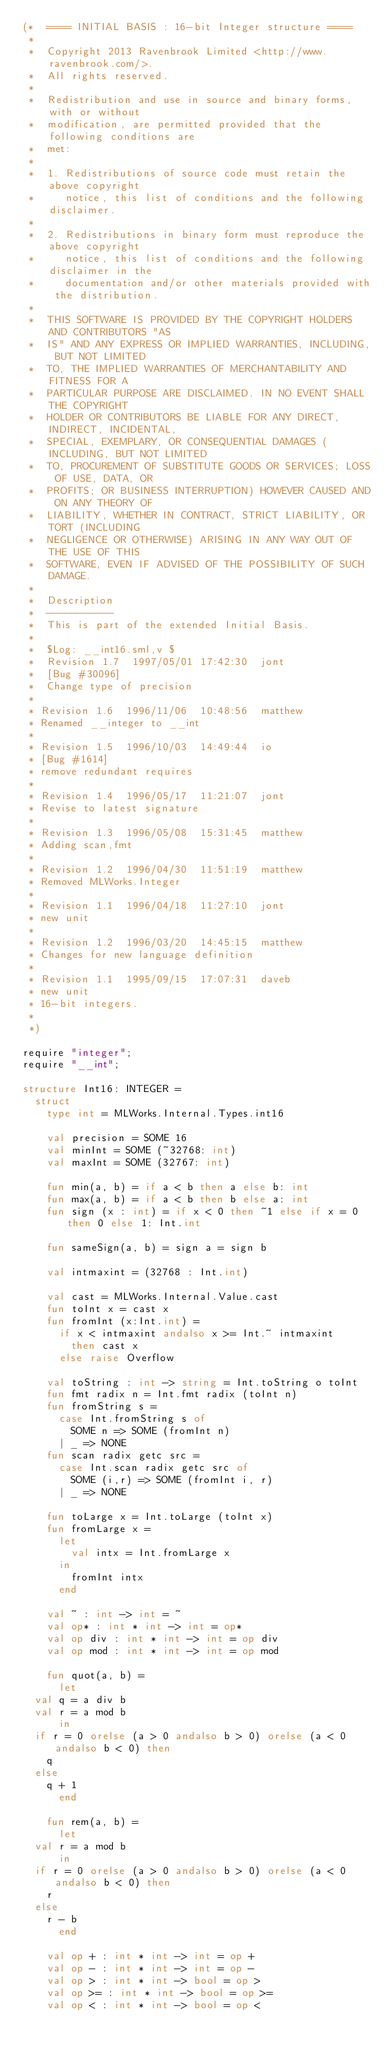<code> <loc_0><loc_0><loc_500><loc_500><_SML_>(*  ==== INITIAL BASIS : 16-bit Integer structure ====
 *
 *  Copyright 2013 Ravenbrook Limited <http://www.ravenbrook.com/>.
 *  All rights reserved.
 *  
 *  Redistribution and use in source and binary forms, with or without
 *  modification, are permitted provided that the following conditions are
 *  met:
 *  
 *  1. Redistributions of source code must retain the above copyright
 *     notice, this list of conditions and the following disclaimer.
 *  
 *  2. Redistributions in binary form must reproduce the above copyright
 *     notice, this list of conditions and the following disclaimer in the
 *     documentation and/or other materials provided with the distribution.
 *  
 *  THIS SOFTWARE IS PROVIDED BY THE COPYRIGHT HOLDERS AND CONTRIBUTORS "AS
 *  IS" AND ANY EXPRESS OR IMPLIED WARRANTIES, INCLUDING, BUT NOT LIMITED
 *  TO, THE IMPLIED WARRANTIES OF MERCHANTABILITY AND FITNESS FOR A
 *  PARTICULAR PURPOSE ARE DISCLAIMED. IN NO EVENT SHALL THE COPYRIGHT
 *  HOLDER OR CONTRIBUTORS BE LIABLE FOR ANY DIRECT, INDIRECT, INCIDENTAL,
 *  SPECIAL, EXEMPLARY, OR CONSEQUENTIAL DAMAGES (INCLUDING, BUT NOT LIMITED
 *  TO, PROCUREMENT OF SUBSTITUTE GOODS OR SERVICES; LOSS OF USE, DATA, OR
 *  PROFITS; OR BUSINESS INTERRUPTION) HOWEVER CAUSED AND ON ANY THEORY OF
 *  LIABILITY, WHETHER IN CONTRACT, STRICT LIABILITY, OR TORT (INCLUDING
 *  NEGLIGENCE OR OTHERWISE) ARISING IN ANY WAY OUT OF THE USE OF THIS
 *  SOFTWARE, EVEN IF ADVISED OF THE POSSIBILITY OF SUCH DAMAGE.
 *
 *  Description
 *  -----------
 *  This is part of the extended Initial Basis.
 *
 *  $Log: __int16.sml,v $
 *  Revision 1.7  1997/05/01 17:42:30  jont
 *  [Bug #30096]
 *  Change type of precision
 *
 * Revision 1.6  1996/11/06  10:48:56  matthew
 * Renamed __integer to __int
 *
 * Revision 1.5  1996/10/03  14:49:44  io
 * [Bug #1614]
 * remove redundant requires
 *
 * Revision 1.4  1996/05/17  11:21:07  jont
 * Revise to latest signature
 *
 * Revision 1.3  1996/05/08  15:31:45  matthew
 * Adding scan,fmt
 *
 * Revision 1.2  1996/04/30  11:51:19  matthew
 * Removed MLWorks.Integer
 *
 * Revision 1.1  1996/04/18  11:27:10  jont
 * new unit
 *
 * Revision 1.2  1996/03/20  14:45:15  matthew
 * Changes for new language definition
 *
 * Revision 1.1  1995/09/15  17:07:31  daveb
 * new unit
 * 16-bit integers.
 *
 *)

require "integer";
require "__int";

structure Int16: INTEGER =
  struct
    type int = MLWorks.Internal.Types.int16

    val precision = SOME 16
    val minInt = SOME (~32768: int)
    val maxInt = SOME (32767: int)

    fun min(a, b) = if a < b then a else b: int
    fun max(a, b) = if a < b then b else a: int
    fun sign (x : int) = if x < 0 then ~1 else if x = 0 then 0 else 1: Int.int

    fun sameSign(a, b) = sign a = sign b

    val intmaxint = (32768 : Int.int)

    val cast = MLWorks.Internal.Value.cast
    fun toInt x = cast x
    fun fromInt (x:Int.int) = 
      if x < intmaxint andalso x >= Int.~ intmaxint
        then cast x
      else raise Overflow

    val toString : int -> string = Int.toString o toInt
    fun fmt radix n = Int.fmt radix (toInt n)
    fun fromString s =
      case Int.fromString s of
        SOME n => SOME (fromInt n)
      | _ => NONE
    fun scan radix getc src =
      case Int.scan radix getc src of
        SOME (i,r) => SOME (fromInt i, r)
      | _ => NONE

    fun toLarge x = Int.toLarge (toInt x)
    fun fromLarge x = 
      let
        val intx = Int.fromLarge x
      in
        fromInt intx
      end

    val ~ : int -> int = ~
    val op* : int * int -> int = op*
    val op div : int * int -> int = op div
    val op mod : int * int -> int = op mod

    fun quot(a, b) =
      let
	val q = a div b
	val r = a mod b
      in
	if r = 0 orelse (a > 0 andalso b > 0) orelse (a < 0 andalso b < 0) then
	  q
	else
	  q + 1
      end

    fun rem(a, b) =
      let
	val r = a mod b
      in
	if r = 0 orelse (a > 0 andalso b > 0) orelse (a < 0 andalso b < 0) then
	  r 
	else
	  r - b
      end

    val op + : int * int -> int = op +
    val op - : int * int -> int = op -
    val op > : int * int -> bool = op >
    val op >= : int * int -> bool = op >=
    val op < : int * int -> bool = op <</code> 